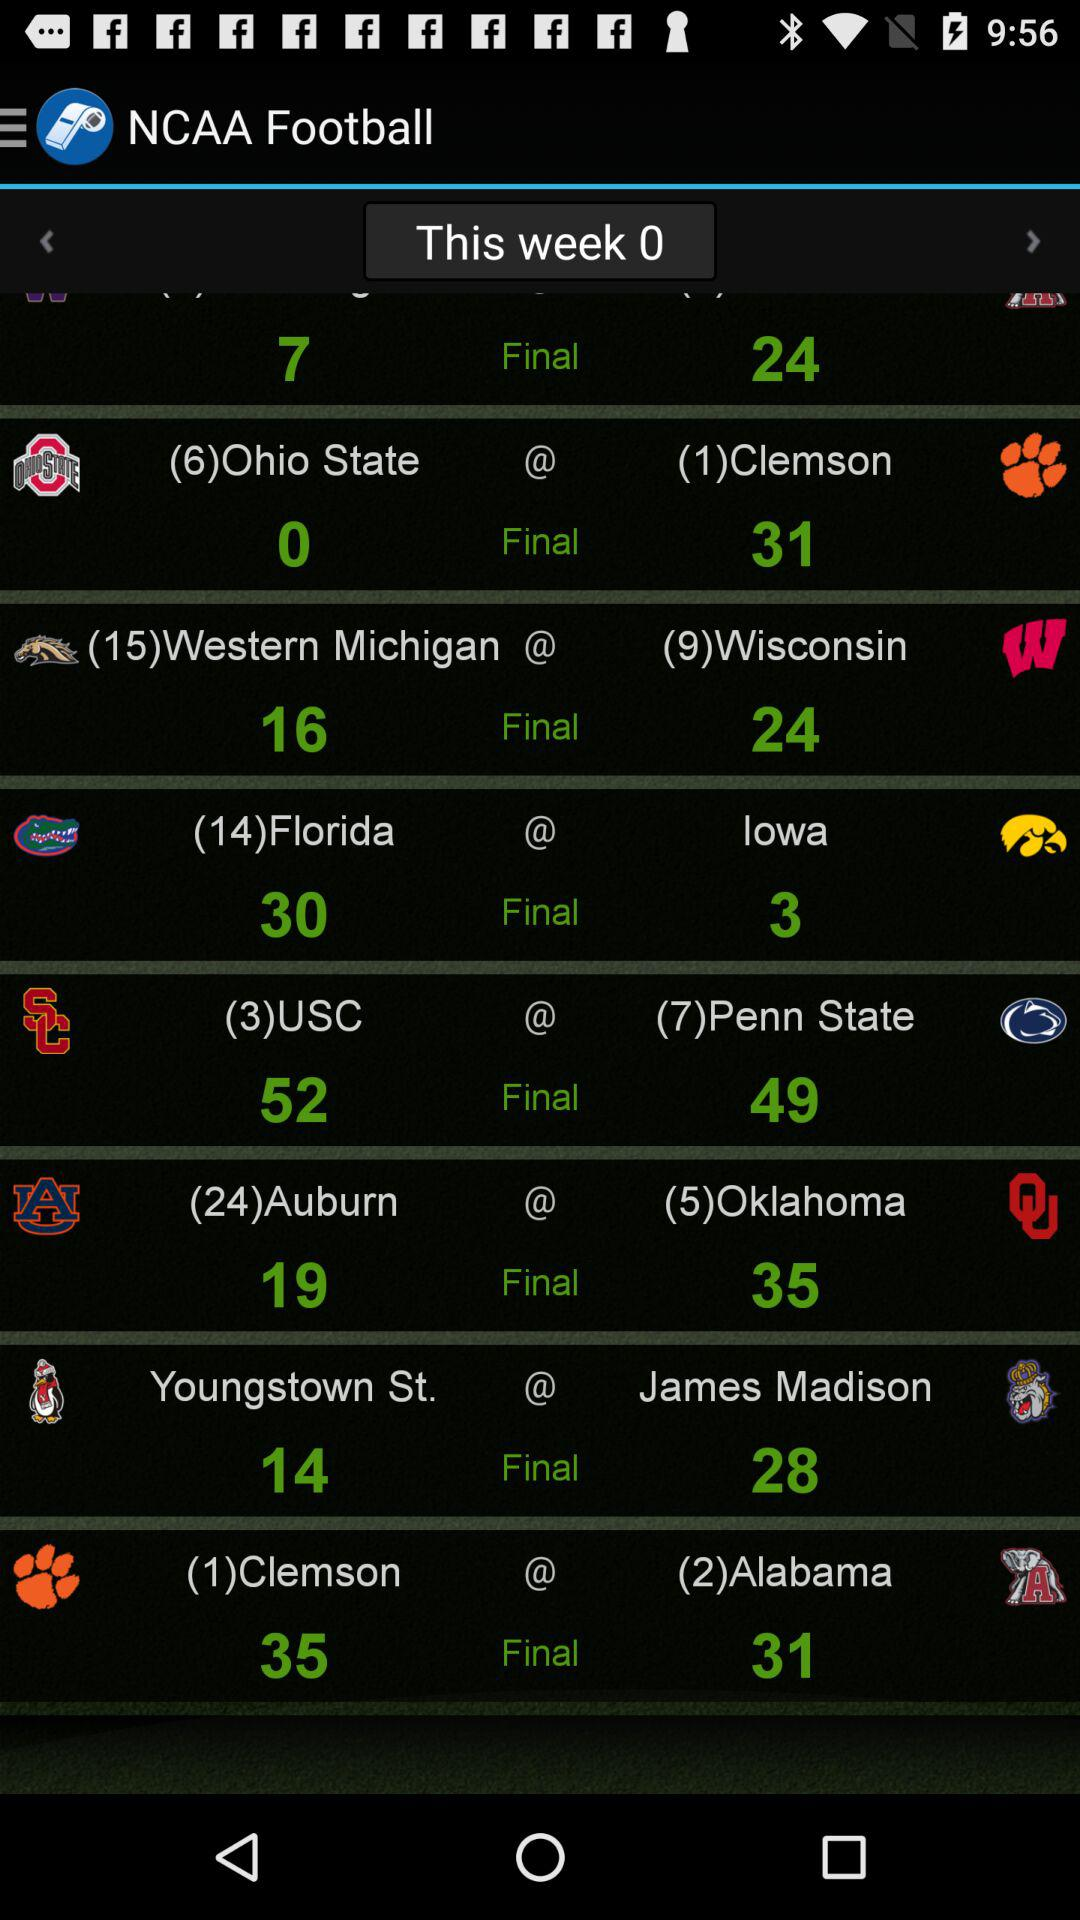What is the user's name?
When the provided information is insufficient, respond with <no answer>. <no answer> 